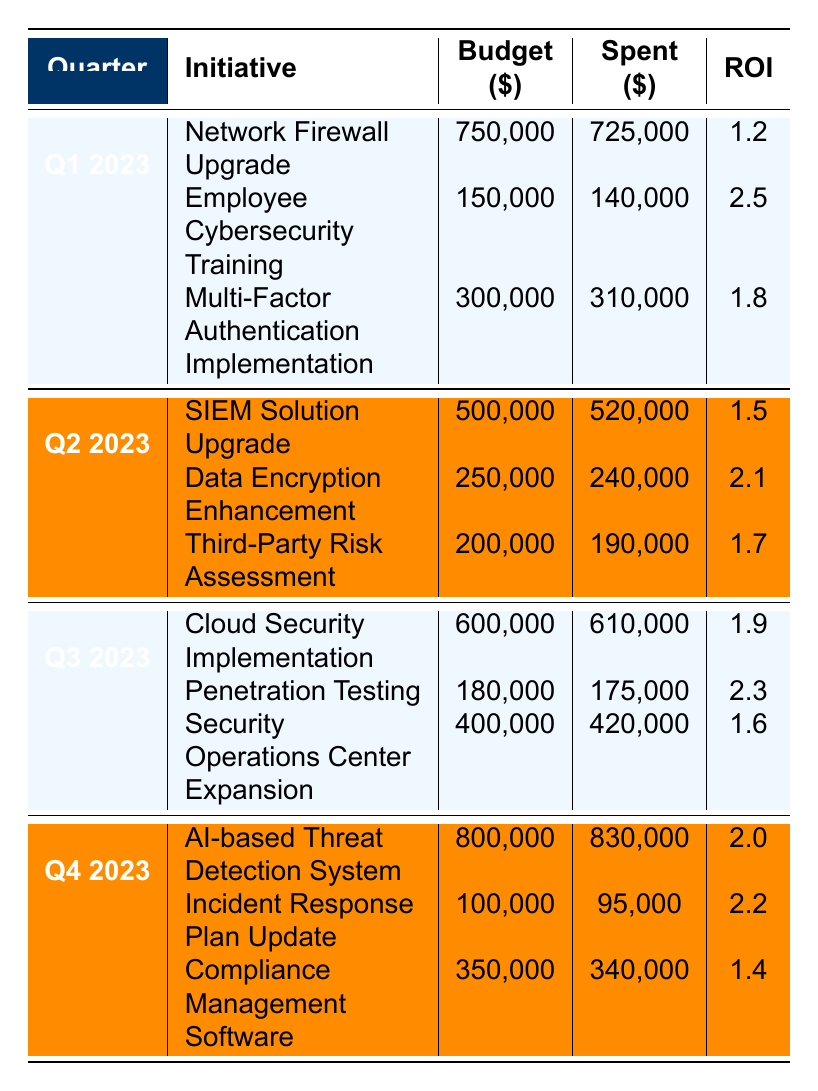What was the total budget allocated for Q1 2023 initiatives? In Q1 2023, the budgets for the initiatives were: Network Firewall Upgrade (750,000), Employee Cybersecurity Training (150,000), and Multi-Factor Authentication Implementation (300,000). Adding these values gives: 750,000 + 150,000 + 300,000 = 1,200,000.
Answer: 1,200,000 Which initiative had the highest ROI in Q2 2023? The initiatives in Q2 2023 and their ROIs are: SIEM Solution Upgrade (1.5), Data Encryption Enhancement (2.1), and Third-Party Risk Assessment (1.7). The highest ROI is from the Data Encryption Enhancement initiative with an ROI of 2.1.
Answer: Data Encryption Enhancement Did we exceed the budget for the Multi-Factor Authentication Implementation in Q1 2023? The budget for Multi-Factor Authentication Implementation was 300,000, and we spent 310,000, which is more than the budget. Therefore, we did exceed the budget.
Answer: Yes What is the average ROI of initiatives across all quarters? To find the average ROI, we sum the ROIs of all initiatives: Q1 (1.2 + 2.5 + 1.8 = 5.5), Q2 (1.5 + 2.1 + 1.7 = 5.3), Q3 (1.9 + 2.3 + 1.6 = 5.8), Q4 (2.0 + 2.2 + 1.4 = 5.6). The total ROI is 5.5 + 5.3 + 5.8 + 5.6 = 22.2 and there are 12 initiatives in total, so the average ROI is 22.2 / 12 = 1.85.
Answer: 1.85 Which quarter had the largest total expenditure? The total expenditures for each quarter are: Q1 (725,000 + 140,000 + 310,000 = 1,175,000), Q2 (520,000 + 240,000 + 190,000 = 950,000), Q3 (610,000 + 175,000 + 420,000 = 1,205,000), Q4 (830,000 + 95,000 + 340,000 = 1,265,000). Q4 has the highest total expenditure of 1,265,000.
Answer: Q4 2023 